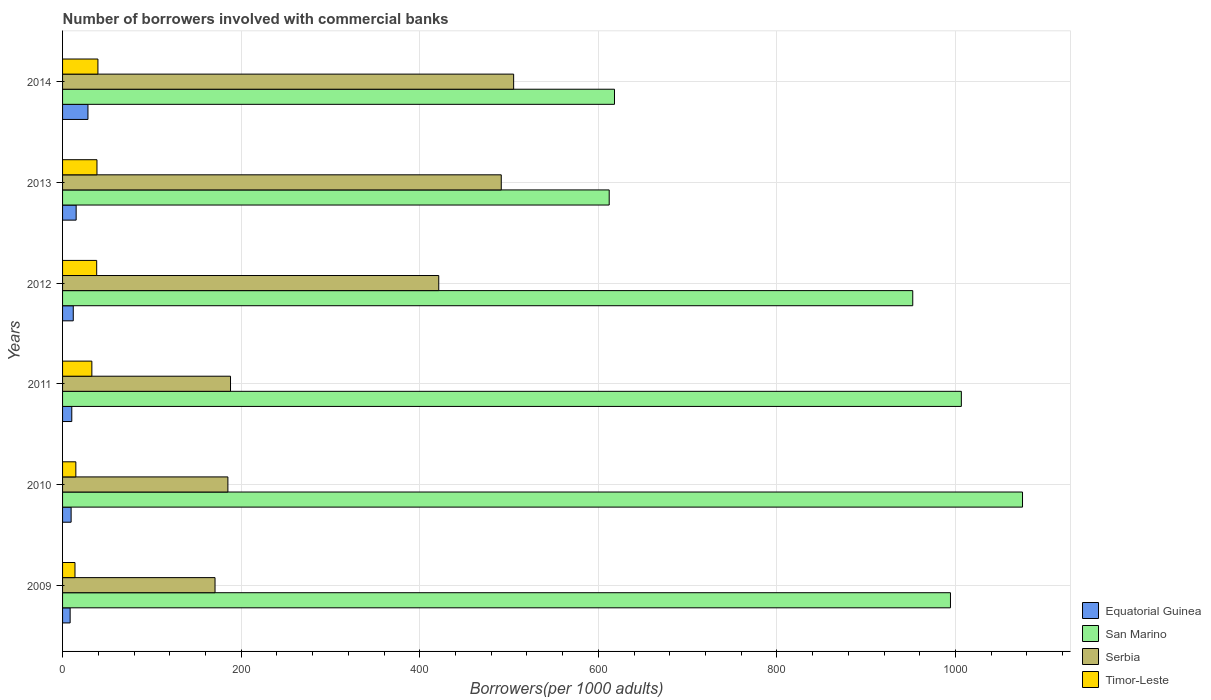What is the label of the 3rd group of bars from the top?
Provide a short and direct response. 2012. What is the number of borrowers involved with commercial banks in San Marino in 2009?
Give a very brief answer. 994.42. Across all years, what is the maximum number of borrowers involved with commercial banks in Equatorial Guinea?
Ensure brevity in your answer.  28.43. Across all years, what is the minimum number of borrowers involved with commercial banks in Serbia?
Offer a very short reply. 170.75. In which year was the number of borrowers involved with commercial banks in Equatorial Guinea minimum?
Offer a very short reply. 2009. What is the total number of borrowers involved with commercial banks in San Marino in the graph?
Give a very brief answer. 5258.57. What is the difference between the number of borrowers involved with commercial banks in Equatorial Guinea in 2012 and that in 2014?
Offer a very short reply. -16.45. What is the difference between the number of borrowers involved with commercial banks in San Marino in 2014 and the number of borrowers involved with commercial banks in Equatorial Guinea in 2013?
Give a very brief answer. 602.9. What is the average number of borrowers involved with commercial banks in Equatorial Guinea per year?
Offer a very short reply. 14. In the year 2013, what is the difference between the number of borrowers involved with commercial banks in Equatorial Guinea and number of borrowers involved with commercial banks in Serbia?
Offer a terse response. -476.1. In how many years, is the number of borrowers involved with commercial banks in Timor-Leste greater than 520 ?
Provide a succinct answer. 0. What is the ratio of the number of borrowers involved with commercial banks in Serbia in 2011 to that in 2013?
Your answer should be very brief. 0.38. Is the difference between the number of borrowers involved with commercial banks in Equatorial Guinea in 2009 and 2010 greater than the difference between the number of borrowers involved with commercial banks in Serbia in 2009 and 2010?
Your answer should be very brief. Yes. What is the difference between the highest and the second highest number of borrowers involved with commercial banks in Timor-Leste?
Keep it short and to the point. 1.07. What is the difference between the highest and the lowest number of borrowers involved with commercial banks in Timor-Leste?
Keep it short and to the point. 25.7. What does the 3rd bar from the top in 2014 represents?
Make the answer very short. San Marino. What does the 1st bar from the bottom in 2014 represents?
Ensure brevity in your answer.  Equatorial Guinea. How many bars are there?
Give a very brief answer. 24. How many years are there in the graph?
Offer a very short reply. 6. What is the difference between two consecutive major ticks on the X-axis?
Offer a terse response. 200. Where does the legend appear in the graph?
Keep it short and to the point. Bottom right. How are the legend labels stacked?
Make the answer very short. Vertical. What is the title of the graph?
Give a very brief answer. Number of borrowers involved with commercial banks. Does "Jordan" appear as one of the legend labels in the graph?
Keep it short and to the point. No. What is the label or title of the X-axis?
Ensure brevity in your answer.  Borrowers(per 1000 adults). What is the label or title of the Y-axis?
Offer a terse response. Years. What is the Borrowers(per 1000 adults) of Equatorial Guinea in 2009?
Your answer should be compact. 8.49. What is the Borrowers(per 1000 adults) of San Marino in 2009?
Your response must be concise. 994.42. What is the Borrowers(per 1000 adults) of Serbia in 2009?
Offer a very short reply. 170.75. What is the Borrowers(per 1000 adults) in Timor-Leste in 2009?
Offer a terse response. 13.9. What is the Borrowers(per 1000 adults) of Equatorial Guinea in 2010?
Keep it short and to the point. 9.58. What is the Borrowers(per 1000 adults) in San Marino in 2010?
Provide a succinct answer. 1075.09. What is the Borrowers(per 1000 adults) of Serbia in 2010?
Offer a terse response. 185.15. What is the Borrowers(per 1000 adults) of Timor-Leste in 2010?
Your response must be concise. 14.87. What is the Borrowers(per 1000 adults) in Equatorial Guinea in 2011?
Your answer should be very brief. 10.32. What is the Borrowers(per 1000 adults) in San Marino in 2011?
Offer a very short reply. 1006.58. What is the Borrowers(per 1000 adults) of Serbia in 2011?
Ensure brevity in your answer.  188.1. What is the Borrowers(per 1000 adults) of Timor-Leste in 2011?
Ensure brevity in your answer.  32.81. What is the Borrowers(per 1000 adults) in Equatorial Guinea in 2012?
Give a very brief answer. 11.98. What is the Borrowers(per 1000 adults) in San Marino in 2012?
Your answer should be compact. 952.16. What is the Borrowers(per 1000 adults) in Serbia in 2012?
Make the answer very short. 421.31. What is the Borrowers(per 1000 adults) of Timor-Leste in 2012?
Keep it short and to the point. 38.21. What is the Borrowers(per 1000 adults) of Equatorial Guinea in 2013?
Keep it short and to the point. 15.22. What is the Borrowers(per 1000 adults) in San Marino in 2013?
Keep it short and to the point. 612.21. What is the Borrowers(per 1000 adults) of Serbia in 2013?
Offer a very short reply. 491.32. What is the Borrowers(per 1000 adults) in Timor-Leste in 2013?
Keep it short and to the point. 38.53. What is the Borrowers(per 1000 adults) of Equatorial Guinea in 2014?
Your answer should be compact. 28.43. What is the Borrowers(per 1000 adults) of San Marino in 2014?
Your answer should be very brief. 618.11. What is the Borrowers(per 1000 adults) of Serbia in 2014?
Make the answer very short. 505.18. What is the Borrowers(per 1000 adults) in Timor-Leste in 2014?
Your response must be concise. 39.6. Across all years, what is the maximum Borrowers(per 1000 adults) in Equatorial Guinea?
Offer a very short reply. 28.43. Across all years, what is the maximum Borrowers(per 1000 adults) of San Marino?
Offer a very short reply. 1075.09. Across all years, what is the maximum Borrowers(per 1000 adults) in Serbia?
Your response must be concise. 505.18. Across all years, what is the maximum Borrowers(per 1000 adults) of Timor-Leste?
Provide a short and direct response. 39.6. Across all years, what is the minimum Borrowers(per 1000 adults) of Equatorial Guinea?
Your answer should be very brief. 8.49. Across all years, what is the minimum Borrowers(per 1000 adults) in San Marino?
Provide a short and direct response. 612.21. Across all years, what is the minimum Borrowers(per 1000 adults) in Serbia?
Your answer should be compact. 170.75. Across all years, what is the minimum Borrowers(per 1000 adults) of Timor-Leste?
Make the answer very short. 13.9. What is the total Borrowers(per 1000 adults) of Equatorial Guinea in the graph?
Offer a terse response. 84.02. What is the total Borrowers(per 1000 adults) of San Marino in the graph?
Keep it short and to the point. 5258.57. What is the total Borrowers(per 1000 adults) in Serbia in the graph?
Provide a short and direct response. 1961.8. What is the total Borrowers(per 1000 adults) in Timor-Leste in the graph?
Offer a terse response. 177.93. What is the difference between the Borrowers(per 1000 adults) of Equatorial Guinea in 2009 and that in 2010?
Your answer should be compact. -1.09. What is the difference between the Borrowers(per 1000 adults) of San Marino in 2009 and that in 2010?
Offer a terse response. -80.68. What is the difference between the Borrowers(per 1000 adults) of Serbia in 2009 and that in 2010?
Make the answer very short. -14.4. What is the difference between the Borrowers(per 1000 adults) in Timor-Leste in 2009 and that in 2010?
Your answer should be compact. -0.97. What is the difference between the Borrowers(per 1000 adults) in Equatorial Guinea in 2009 and that in 2011?
Keep it short and to the point. -1.83. What is the difference between the Borrowers(per 1000 adults) of San Marino in 2009 and that in 2011?
Provide a short and direct response. -12.17. What is the difference between the Borrowers(per 1000 adults) in Serbia in 2009 and that in 2011?
Keep it short and to the point. -17.35. What is the difference between the Borrowers(per 1000 adults) in Timor-Leste in 2009 and that in 2011?
Provide a succinct answer. -18.91. What is the difference between the Borrowers(per 1000 adults) in Equatorial Guinea in 2009 and that in 2012?
Keep it short and to the point. -3.5. What is the difference between the Borrowers(per 1000 adults) in San Marino in 2009 and that in 2012?
Offer a very short reply. 42.26. What is the difference between the Borrowers(per 1000 adults) of Serbia in 2009 and that in 2012?
Your response must be concise. -250.56. What is the difference between the Borrowers(per 1000 adults) in Timor-Leste in 2009 and that in 2012?
Your response must be concise. -24.31. What is the difference between the Borrowers(per 1000 adults) in Equatorial Guinea in 2009 and that in 2013?
Offer a very short reply. -6.73. What is the difference between the Borrowers(per 1000 adults) of San Marino in 2009 and that in 2013?
Give a very brief answer. 382.2. What is the difference between the Borrowers(per 1000 adults) of Serbia in 2009 and that in 2013?
Give a very brief answer. -320.56. What is the difference between the Borrowers(per 1000 adults) of Timor-Leste in 2009 and that in 2013?
Your answer should be very brief. -24.63. What is the difference between the Borrowers(per 1000 adults) in Equatorial Guinea in 2009 and that in 2014?
Provide a succinct answer. -19.94. What is the difference between the Borrowers(per 1000 adults) in San Marino in 2009 and that in 2014?
Offer a very short reply. 376.3. What is the difference between the Borrowers(per 1000 adults) in Serbia in 2009 and that in 2014?
Make the answer very short. -334.43. What is the difference between the Borrowers(per 1000 adults) in Timor-Leste in 2009 and that in 2014?
Keep it short and to the point. -25.7. What is the difference between the Borrowers(per 1000 adults) in Equatorial Guinea in 2010 and that in 2011?
Your response must be concise. -0.74. What is the difference between the Borrowers(per 1000 adults) of San Marino in 2010 and that in 2011?
Offer a very short reply. 68.51. What is the difference between the Borrowers(per 1000 adults) of Serbia in 2010 and that in 2011?
Your answer should be very brief. -2.94. What is the difference between the Borrowers(per 1000 adults) in Timor-Leste in 2010 and that in 2011?
Offer a very short reply. -17.94. What is the difference between the Borrowers(per 1000 adults) of Equatorial Guinea in 2010 and that in 2012?
Your answer should be compact. -2.41. What is the difference between the Borrowers(per 1000 adults) of San Marino in 2010 and that in 2012?
Offer a very short reply. 122.93. What is the difference between the Borrowers(per 1000 adults) of Serbia in 2010 and that in 2012?
Your response must be concise. -236.15. What is the difference between the Borrowers(per 1000 adults) of Timor-Leste in 2010 and that in 2012?
Give a very brief answer. -23.34. What is the difference between the Borrowers(per 1000 adults) in Equatorial Guinea in 2010 and that in 2013?
Give a very brief answer. -5.64. What is the difference between the Borrowers(per 1000 adults) in San Marino in 2010 and that in 2013?
Your answer should be compact. 462.88. What is the difference between the Borrowers(per 1000 adults) in Serbia in 2010 and that in 2013?
Ensure brevity in your answer.  -306.16. What is the difference between the Borrowers(per 1000 adults) in Timor-Leste in 2010 and that in 2013?
Keep it short and to the point. -23.66. What is the difference between the Borrowers(per 1000 adults) of Equatorial Guinea in 2010 and that in 2014?
Provide a succinct answer. -18.86. What is the difference between the Borrowers(per 1000 adults) in San Marino in 2010 and that in 2014?
Provide a succinct answer. 456.98. What is the difference between the Borrowers(per 1000 adults) in Serbia in 2010 and that in 2014?
Ensure brevity in your answer.  -320.02. What is the difference between the Borrowers(per 1000 adults) of Timor-Leste in 2010 and that in 2014?
Provide a succinct answer. -24.73. What is the difference between the Borrowers(per 1000 adults) in Equatorial Guinea in 2011 and that in 2012?
Your answer should be compact. -1.67. What is the difference between the Borrowers(per 1000 adults) of San Marino in 2011 and that in 2012?
Give a very brief answer. 54.42. What is the difference between the Borrowers(per 1000 adults) in Serbia in 2011 and that in 2012?
Offer a terse response. -233.21. What is the difference between the Borrowers(per 1000 adults) of Timor-Leste in 2011 and that in 2012?
Your response must be concise. -5.4. What is the difference between the Borrowers(per 1000 adults) of Equatorial Guinea in 2011 and that in 2013?
Provide a succinct answer. -4.9. What is the difference between the Borrowers(per 1000 adults) in San Marino in 2011 and that in 2013?
Keep it short and to the point. 394.37. What is the difference between the Borrowers(per 1000 adults) of Serbia in 2011 and that in 2013?
Your answer should be very brief. -303.22. What is the difference between the Borrowers(per 1000 adults) of Timor-Leste in 2011 and that in 2013?
Your answer should be compact. -5.72. What is the difference between the Borrowers(per 1000 adults) in Equatorial Guinea in 2011 and that in 2014?
Ensure brevity in your answer.  -18.12. What is the difference between the Borrowers(per 1000 adults) in San Marino in 2011 and that in 2014?
Your answer should be very brief. 388.47. What is the difference between the Borrowers(per 1000 adults) in Serbia in 2011 and that in 2014?
Provide a succinct answer. -317.08. What is the difference between the Borrowers(per 1000 adults) of Timor-Leste in 2011 and that in 2014?
Make the answer very short. -6.79. What is the difference between the Borrowers(per 1000 adults) of Equatorial Guinea in 2012 and that in 2013?
Make the answer very short. -3.23. What is the difference between the Borrowers(per 1000 adults) in San Marino in 2012 and that in 2013?
Make the answer very short. 339.95. What is the difference between the Borrowers(per 1000 adults) in Serbia in 2012 and that in 2013?
Ensure brevity in your answer.  -70.01. What is the difference between the Borrowers(per 1000 adults) in Timor-Leste in 2012 and that in 2013?
Provide a short and direct response. -0.32. What is the difference between the Borrowers(per 1000 adults) in Equatorial Guinea in 2012 and that in 2014?
Your response must be concise. -16.45. What is the difference between the Borrowers(per 1000 adults) in San Marino in 2012 and that in 2014?
Give a very brief answer. 334.05. What is the difference between the Borrowers(per 1000 adults) in Serbia in 2012 and that in 2014?
Make the answer very short. -83.87. What is the difference between the Borrowers(per 1000 adults) in Timor-Leste in 2012 and that in 2014?
Provide a short and direct response. -1.39. What is the difference between the Borrowers(per 1000 adults) of Equatorial Guinea in 2013 and that in 2014?
Your response must be concise. -13.22. What is the difference between the Borrowers(per 1000 adults) of San Marino in 2013 and that in 2014?
Your response must be concise. -5.9. What is the difference between the Borrowers(per 1000 adults) of Serbia in 2013 and that in 2014?
Your answer should be very brief. -13.86. What is the difference between the Borrowers(per 1000 adults) in Timor-Leste in 2013 and that in 2014?
Offer a terse response. -1.07. What is the difference between the Borrowers(per 1000 adults) in Equatorial Guinea in 2009 and the Borrowers(per 1000 adults) in San Marino in 2010?
Make the answer very short. -1066.6. What is the difference between the Borrowers(per 1000 adults) in Equatorial Guinea in 2009 and the Borrowers(per 1000 adults) in Serbia in 2010?
Offer a very short reply. -176.66. What is the difference between the Borrowers(per 1000 adults) in Equatorial Guinea in 2009 and the Borrowers(per 1000 adults) in Timor-Leste in 2010?
Offer a terse response. -6.38. What is the difference between the Borrowers(per 1000 adults) of San Marino in 2009 and the Borrowers(per 1000 adults) of Serbia in 2010?
Make the answer very short. 809.26. What is the difference between the Borrowers(per 1000 adults) of San Marino in 2009 and the Borrowers(per 1000 adults) of Timor-Leste in 2010?
Offer a very short reply. 979.55. What is the difference between the Borrowers(per 1000 adults) of Serbia in 2009 and the Borrowers(per 1000 adults) of Timor-Leste in 2010?
Give a very brief answer. 155.88. What is the difference between the Borrowers(per 1000 adults) of Equatorial Guinea in 2009 and the Borrowers(per 1000 adults) of San Marino in 2011?
Your response must be concise. -998.09. What is the difference between the Borrowers(per 1000 adults) of Equatorial Guinea in 2009 and the Borrowers(per 1000 adults) of Serbia in 2011?
Keep it short and to the point. -179.61. What is the difference between the Borrowers(per 1000 adults) of Equatorial Guinea in 2009 and the Borrowers(per 1000 adults) of Timor-Leste in 2011?
Keep it short and to the point. -24.32. What is the difference between the Borrowers(per 1000 adults) of San Marino in 2009 and the Borrowers(per 1000 adults) of Serbia in 2011?
Your response must be concise. 806.32. What is the difference between the Borrowers(per 1000 adults) in San Marino in 2009 and the Borrowers(per 1000 adults) in Timor-Leste in 2011?
Your answer should be compact. 961.6. What is the difference between the Borrowers(per 1000 adults) in Serbia in 2009 and the Borrowers(per 1000 adults) in Timor-Leste in 2011?
Offer a terse response. 137.94. What is the difference between the Borrowers(per 1000 adults) of Equatorial Guinea in 2009 and the Borrowers(per 1000 adults) of San Marino in 2012?
Ensure brevity in your answer.  -943.67. What is the difference between the Borrowers(per 1000 adults) in Equatorial Guinea in 2009 and the Borrowers(per 1000 adults) in Serbia in 2012?
Provide a short and direct response. -412.82. What is the difference between the Borrowers(per 1000 adults) of Equatorial Guinea in 2009 and the Borrowers(per 1000 adults) of Timor-Leste in 2012?
Provide a succinct answer. -29.72. What is the difference between the Borrowers(per 1000 adults) in San Marino in 2009 and the Borrowers(per 1000 adults) in Serbia in 2012?
Give a very brief answer. 573.11. What is the difference between the Borrowers(per 1000 adults) of San Marino in 2009 and the Borrowers(per 1000 adults) of Timor-Leste in 2012?
Your answer should be very brief. 956.21. What is the difference between the Borrowers(per 1000 adults) in Serbia in 2009 and the Borrowers(per 1000 adults) in Timor-Leste in 2012?
Offer a terse response. 132.54. What is the difference between the Borrowers(per 1000 adults) of Equatorial Guinea in 2009 and the Borrowers(per 1000 adults) of San Marino in 2013?
Provide a succinct answer. -603.72. What is the difference between the Borrowers(per 1000 adults) of Equatorial Guinea in 2009 and the Borrowers(per 1000 adults) of Serbia in 2013?
Keep it short and to the point. -482.83. What is the difference between the Borrowers(per 1000 adults) of Equatorial Guinea in 2009 and the Borrowers(per 1000 adults) of Timor-Leste in 2013?
Keep it short and to the point. -30.04. What is the difference between the Borrowers(per 1000 adults) of San Marino in 2009 and the Borrowers(per 1000 adults) of Serbia in 2013?
Your answer should be compact. 503.1. What is the difference between the Borrowers(per 1000 adults) of San Marino in 2009 and the Borrowers(per 1000 adults) of Timor-Leste in 2013?
Provide a succinct answer. 955.88. What is the difference between the Borrowers(per 1000 adults) in Serbia in 2009 and the Borrowers(per 1000 adults) in Timor-Leste in 2013?
Your answer should be compact. 132.22. What is the difference between the Borrowers(per 1000 adults) of Equatorial Guinea in 2009 and the Borrowers(per 1000 adults) of San Marino in 2014?
Ensure brevity in your answer.  -609.62. What is the difference between the Borrowers(per 1000 adults) of Equatorial Guinea in 2009 and the Borrowers(per 1000 adults) of Serbia in 2014?
Provide a succinct answer. -496.69. What is the difference between the Borrowers(per 1000 adults) in Equatorial Guinea in 2009 and the Borrowers(per 1000 adults) in Timor-Leste in 2014?
Your answer should be very brief. -31.11. What is the difference between the Borrowers(per 1000 adults) in San Marino in 2009 and the Borrowers(per 1000 adults) in Serbia in 2014?
Your answer should be very brief. 489.24. What is the difference between the Borrowers(per 1000 adults) of San Marino in 2009 and the Borrowers(per 1000 adults) of Timor-Leste in 2014?
Your answer should be compact. 954.81. What is the difference between the Borrowers(per 1000 adults) in Serbia in 2009 and the Borrowers(per 1000 adults) in Timor-Leste in 2014?
Ensure brevity in your answer.  131.15. What is the difference between the Borrowers(per 1000 adults) of Equatorial Guinea in 2010 and the Borrowers(per 1000 adults) of San Marino in 2011?
Your answer should be compact. -997. What is the difference between the Borrowers(per 1000 adults) in Equatorial Guinea in 2010 and the Borrowers(per 1000 adults) in Serbia in 2011?
Keep it short and to the point. -178.52. What is the difference between the Borrowers(per 1000 adults) in Equatorial Guinea in 2010 and the Borrowers(per 1000 adults) in Timor-Leste in 2011?
Provide a succinct answer. -23.23. What is the difference between the Borrowers(per 1000 adults) of San Marino in 2010 and the Borrowers(per 1000 adults) of Serbia in 2011?
Your answer should be very brief. 886.99. What is the difference between the Borrowers(per 1000 adults) of San Marino in 2010 and the Borrowers(per 1000 adults) of Timor-Leste in 2011?
Make the answer very short. 1042.28. What is the difference between the Borrowers(per 1000 adults) in Serbia in 2010 and the Borrowers(per 1000 adults) in Timor-Leste in 2011?
Your answer should be compact. 152.34. What is the difference between the Borrowers(per 1000 adults) of Equatorial Guinea in 2010 and the Borrowers(per 1000 adults) of San Marino in 2012?
Offer a terse response. -942.58. What is the difference between the Borrowers(per 1000 adults) in Equatorial Guinea in 2010 and the Borrowers(per 1000 adults) in Serbia in 2012?
Give a very brief answer. -411.73. What is the difference between the Borrowers(per 1000 adults) in Equatorial Guinea in 2010 and the Borrowers(per 1000 adults) in Timor-Leste in 2012?
Make the answer very short. -28.63. What is the difference between the Borrowers(per 1000 adults) in San Marino in 2010 and the Borrowers(per 1000 adults) in Serbia in 2012?
Offer a terse response. 653.78. What is the difference between the Borrowers(per 1000 adults) in San Marino in 2010 and the Borrowers(per 1000 adults) in Timor-Leste in 2012?
Give a very brief answer. 1036.88. What is the difference between the Borrowers(per 1000 adults) of Serbia in 2010 and the Borrowers(per 1000 adults) of Timor-Leste in 2012?
Keep it short and to the point. 146.95. What is the difference between the Borrowers(per 1000 adults) of Equatorial Guinea in 2010 and the Borrowers(per 1000 adults) of San Marino in 2013?
Provide a succinct answer. -602.63. What is the difference between the Borrowers(per 1000 adults) in Equatorial Guinea in 2010 and the Borrowers(per 1000 adults) in Serbia in 2013?
Your answer should be very brief. -481.74. What is the difference between the Borrowers(per 1000 adults) of Equatorial Guinea in 2010 and the Borrowers(per 1000 adults) of Timor-Leste in 2013?
Provide a succinct answer. -28.96. What is the difference between the Borrowers(per 1000 adults) in San Marino in 2010 and the Borrowers(per 1000 adults) in Serbia in 2013?
Keep it short and to the point. 583.78. What is the difference between the Borrowers(per 1000 adults) in San Marino in 2010 and the Borrowers(per 1000 adults) in Timor-Leste in 2013?
Give a very brief answer. 1036.56. What is the difference between the Borrowers(per 1000 adults) in Serbia in 2010 and the Borrowers(per 1000 adults) in Timor-Leste in 2013?
Provide a succinct answer. 146.62. What is the difference between the Borrowers(per 1000 adults) in Equatorial Guinea in 2010 and the Borrowers(per 1000 adults) in San Marino in 2014?
Offer a very short reply. -608.54. What is the difference between the Borrowers(per 1000 adults) in Equatorial Guinea in 2010 and the Borrowers(per 1000 adults) in Serbia in 2014?
Ensure brevity in your answer.  -495.6. What is the difference between the Borrowers(per 1000 adults) of Equatorial Guinea in 2010 and the Borrowers(per 1000 adults) of Timor-Leste in 2014?
Keep it short and to the point. -30.03. What is the difference between the Borrowers(per 1000 adults) of San Marino in 2010 and the Borrowers(per 1000 adults) of Serbia in 2014?
Your response must be concise. 569.91. What is the difference between the Borrowers(per 1000 adults) of San Marino in 2010 and the Borrowers(per 1000 adults) of Timor-Leste in 2014?
Your answer should be very brief. 1035.49. What is the difference between the Borrowers(per 1000 adults) of Serbia in 2010 and the Borrowers(per 1000 adults) of Timor-Leste in 2014?
Your response must be concise. 145.55. What is the difference between the Borrowers(per 1000 adults) in Equatorial Guinea in 2011 and the Borrowers(per 1000 adults) in San Marino in 2012?
Your answer should be compact. -941.84. What is the difference between the Borrowers(per 1000 adults) of Equatorial Guinea in 2011 and the Borrowers(per 1000 adults) of Serbia in 2012?
Your response must be concise. -410.99. What is the difference between the Borrowers(per 1000 adults) of Equatorial Guinea in 2011 and the Borrowers(per 1000 adults) of Timor-Leste in 2012?
Your answer should be compact. -27.89. What is the difference between the Borrowers(per 1000 adults) in San Marino in 2011 and the Borrowers(per 1000 adults) in Serbia in 2012?
Ensure brevity in your answer.  585.27. What is the difference between the Borrowers(per 1000 adults) in San Marino in 2011 and the Borrowers(per 1000 adults) in Timor-Leste in 2012?
Make the answer very short. 968.37. What is the difference between the Borrowers(per 1000 adults) of Serbia in 2011 and the Borrowers(per 1000 adults) of Timor-Leste in 2012?
Your answer should be compact. 149.89. What is the difference between the Borrowers(per 1000 adults) in Equatorial Guinea in 2011 and the Borrowers(per 1000 adults) in San Marino in 2013?
Your answer should be compact. -601.89. What is the difference between the Borrowers(per 1000 adults) of Equatorial Guinea in 2011 and the Borrowers(per 1000 adults) of Serbia in 2013?
Offer a terse response. -481. What is the difference between the Borrowers(per 1000 adults) in Equatorial Guinea in 2011 and the Borrowers(per 1000 adults) in Timor-Leste in 2013?
Your answer should be compact. -28.22. What is the difference between the Borrowers(per 1000 adults) of San Marino in 2011 and the Borrowers(per 1000 adults) of Serbia in 2013?
Ensure brevity in your answer.  515.27. What is the difference between the Borrowers(per 1000 adults) in San Marino in 2011 and the Borrowers(per 1000 adults) in Timor-Leste in 2013?
Give a very brief answer. 968.05. What is the difference between the Borrowers(per 1000 adults) in Serbia in 2011 and the Borrowers(per 1000 adults) in Timor-Leste in 2013?
Provide a short and direct response. 149.56. What is the difference between the Borrowers(per 1000 adults) in Equatorial Guinea in 2011 and the Borrowers(per 1000 adults) in San Marino in 2014?
Provide a succinct answer. -607.8. What is the difference between the Borrowers(per 1000 adults) in Equatorial Guinea in 2011 and the Borrowers(per 1000 adults) in Serbia in 2014?
Provide a short and direct response. -494.86. What is the difference between the Borrowers(per 1000 adults) of Equatorial Guinea in 2011 and the Borrowers(per 1000 adults) of Timor-Leste in 2014?
Offer a terse response. -29.28. What is the difference between the Borrowers(per 1000 adults) in San Marino in 2011 and the Borrowers(per 1000 adults) in Serbia in 2014?
Ensure brevity in your answer.  501.41. What is the difference between the Borrowers(per 1000 adults) in San Marino in 2011 and the Borrowers(per 1000 adults) in Timor-Leste in 2014?
Offer a terse response. 966.98. What is the difference between the Borrowers(per 1000 adults) of Serbia in 2011 and the Borrowers(per 1000 adults) of Timor-Leste in 2014?
Offer a very short reply. 148.5. What is the difference between the Borrowers(per 1000 adults) of Equatorial Guinea in 2012 and the Borrowers(per 1000 adults) of San Marino in 2013?
Your answer should be compact. -600.23. What is the difference between the Borrowers(per 1000 adults) in Equatorial Guinea in 2012 and the Borrowers(per 1000 adults) in Serbia in 2013?
Offer a terse response. -479.33. What is the difference between the Borrowers(per 1000 adults) of Equatorial Guinea in 2012 and the Borrowers(per 1000 adults) of Timor-Leste in 2013?
Keep it short and to the point. -26.55. What is the difference between the Borrowers(per 1000 adults) in San Marino in 2012 and the Borrowers(per 1000 adults) in Serbia in 2013?
Keep it short and to the point. 460.84. What is the difference between the Borrowers(per 1000 adults) of San Marino in 2012 and the Borrowers(per 1000 adults) of Timor-Leste in 2013?
Your answer should be compact. 913.63. What is the difference between the Borrowers(per 1000 adults) of Serbia in 2012 and the Borrowers(per 1000 adults) of Timor-Leste in 2013?
Give a very brief answer. 382.77. What is the difference between the Borrowers(per 1000 adults) in Equatorial Guinea in 2012 and the Borrowers(per 1000 adults) in San Marino in 2014?
Ensure brevity in your answer.  -606.13. What is the difference between the Borrowers(per 1000 adults) of Equatorial Guinea in 2012 and the Borrowers(per 1000 adults) of Serbia in 2014?
Provide a short and direct response. -493.19. What is the difference between the Borrowers(per 1000 adults) of Equatorial Guinea in 2012 and the Borrowers(per 1000 adults) of Timor-Leste in 2014?
Give a very brief answer. -27.62. What is the difference between the Borrowers(per 1000 adults) in San Marino in 2012 and the Borrowers(per 1000 adults) in Serbia in 2014?
Keep it short and to the point. 446.98. What is the difference between the Borrowers(per 1000 adults) of San Marino in 2012 and the Borrowers(per 1000 adults) of Timor-Leste in 2014?
Your answer should be compact. 912.56. What is the difference between the Borrowers(per 1000 adults) of Serbia in 2012 and the Borrowers(per 1000 adults) of Timor-Leste in 2014?
Your answer should be compact. 381.71. What is the difference between the Borrowers(per 1000 adults) of Equatorial Guinea in 2013 and the Borrowers(per 1000 adults) of San Marino in 2014?
Your answer should be very brief. -602.9. What is the difference between the Borrowers(per 1000 adults) of Equatorial Guinea in 2013 and the Borrowers(per 1000 adults) of Serbia in 2014?
Keep it short and to the point. -489.96. What is the difference between the Borrowers(per 1000 adults) of Equatorial Guinea in 2013 and the Borrowers(per 1000 adults) of Timor-Leste in 2014?
Your answer should be compact. -24.39. What is the difference between the Borrowers(per 1000 adults) in San Marino in 2013 and the Borrowers(per 1000 adults) in Serbia in 2014?
Keep it short and to the point. 107.04. What is the difference between the Borrowers(per 1000 adults) of San Marino in 2013 and the Borrowers(per 1000 adults) of Timor-Leste in 2014?
Offer a terse response. 572.61. What is the difference between the Borrowers(per 1000 adults) in Serbia in 2013 and the Borrowers(per 1000 adults) in Timor-Leste in 2014?
Your answer should be compact. 451.71. What is the average Borrowers(per 1000 adults) in Equatorial Guinea per year?
Your answer should be compact. 14. What is the average Borrowers(per 1000 adults) of San Marino per year?
Give a very brief answer. 876.43. What is the average Borrowers(per 1000 adults) of Serbia per year?
Your answer should be very brief. 326.97. What is the average Borrowers(per 1000 adults) of Timor-Leste per year?
Your answer should be compact. 29.65. In the year 2009, what is the difference between the Borrowers(per 1000 adults) of Equatorial Guinea and Borrowers(per 1000 adults) of San Marino?
Keep it short and to the point. -985.93. In the year 2009, what is the difference between the Borrowers(per 1000 adults) of Equatorial Guinea and Borrowers(per 1000 adults) of Serbia?
Keep it short and to the point. -162.26. In the year 2009, what is the difference between the Borrowers(per 1000 adults) of Equatorial Guinea and Borrowers(per 1000 adults) of Timor-Leste?
Provide a succinct answer. -5.41. In the year 2009, what is the difference between the Borrowers(per 1000 adults) in San Marino and Borrowers(per 1000 adults) in Serbia?
Provide a short and direct response. 823.66. In the year 2009, what is the difference between the Borrowers(per 1000 adults) of San Marino and Borrowers(per 1000 adults) of Timor-Leste?
Keep it short and to the point. 980.51. In the year 2009, what is the difference between the Borrowers(per 1000 adults) of Serbia and Borrowers(per 1000 adults) of Timor-Leste?
Make the answer very short. 156.85. In the year 2010, what is the difference between the Borrowers(per 1000 adults) of Equatorial Guinea and Borrowers(per 1000 adults) of San Marino?
Provide a short and direct response. -1065.51. In the year 2010, what is the difference between the Borrowers(per 1000 adults) of Equatorial Guinea and Borrowers(per 1000 adults) of Serbia?
Provide a short and direct response. -175.58. In the year 2010, what is the difference between the Borrowers(per 1000 adults) of Equatorial Guinea and Borrowers(per 1000 adults) of Timor-Leste?
Ensure brevity in your answer.  -5.29. In the year 2010, what is the difference between the Borrowers(per 1000 adults) of San Marino and Borrowers(per 1000 adults) of Serbia?
Make the answer very short. 889.94. In the year 2010, what is the difference between the Borrowers(per 1000 adults) in San Marino and Borrowers(per 1000 adults) in Timor-Leste?
Offer a very short reply. 1060.22. In the year 2010, what is the difference between the Borrowers(per 1000 adults) in Serbia and Borrowers(per 1000 adults) in Timor-Leste?
Provide a succinct answer. 170.28. In the year 2011, what is the difference between the Borrowers(per 1000 adults) of Equatorial Guinea and Borrowers(per 1000 adults) of San Marino?
Your response must be concise. -996.26. In the year 2011, what is the difference between the Borrowers(per 1000 adults) of Equatorial Guinea and Borrowers(per 1000 adults) of Serbia?
Keep it short and to the point. -177.78. In the year 2011, what is the difference between the Borrowers(per 1000 adults) of Equatorial Guinea and Borrowers(per 1000 adults) of Timor-Leste?
Your response must be concise. -22.49. In the year 2011, what is the difference between the Borrowers(per 1000 adults) of San Marino and Borrowers(per 1000 adults) of Serbia?
Your response must be concise. 818.48. In the year 2011, what is the difference between the Borrowers(per 1000 adults) in San Marino and Borrowers(per 1000 adults) in Timor-Leste?
Provide a short and direct response. 973.77. In the year 2011, what is the difference between the Borrowers(per 1000 adults) of Serbia and Borrowers(per 1000 adults) of Timor-Leste?
Provide a short and direct response. 155.29. In the year 2012, what is the difference between the Borrowers(per 1000 adults) in Equatorial Guinea and Borrowers(per 1000 adults) in San Marino?
Offer a very short reply. -940.18. In the year 2012, what is the difference between the Borrowers(per 1000 adults) in Equatorial Guinea and Borrowers(per 1000 adults) in Serbia?
Make the answer very short. -409.32. In the year 2012, what is the difference between the Borrowers(per 1000 adults) of Equatorial Guinea and Borrowers(per 1000 adults) of Timor-Leste?
Offer a terse response. -26.22. In the year 2012, what is the difference between the Borrowers(per 1000 adults) in San Marino and Borrowers(per 1000 adults) in Serbia?
Your answer should be very brief. 530.85. In the year 2012, what is the difference between the Borrowers(per 1000 adults) of San Marino and Borrowers(per 1000 adults) of Timor-Leste?
Provide a succinct answer. 913.95. In the year 2012, what is the difference between the Borrowers(per 1000 adults) in Serbia and Borrowers(per 1000 adults) in Timor-Leste?
Make the answer very short. 383.1. In the year 2013, what is the difference between the Borrowers(per 1000 adults) in Equatorial Guinea and Borrowers(per 1000 adults) in San Marino?
Keep it short and to the point. -597. In the year 2013, what is the difference between the Borrowers(per 1000 adults) of Equatorial Guinea and Borrowers(per 1000 adults) of Serbia?
Your response must be concise. -476.1. In the year 2013, what is the difference between the Borrowers(per 1000 adults) of Equatorial Guinea and Borrowers(per 1000 adults) of Timor-Leste?
Provide a short and direct response. -23.32. In the year 2013, what is the difference between the Borrowers(per 1000 adults) of San Marino and Borrowers(per 1000 adults) of Serbia?
Provide a short and direct response. 120.9. In the year 2013, what is the difference between the Borrowers(per 1000 adults) of San Marino and Borrowers(per 1000 adults) of Timor-Leste?
Provide a succinct answer. 573.68. In the year 2013, what is the difference between the Borrowers(per 1000 adults) of Serbia and Borrowers(per 1000 adults) of Timor-Leste?
Offer a terse response. 452.78. In the year 2014, what is the difference between the Borrowers(per 1000 adults) of Equatorial Guinea and Borrowers(per 1000 adults) of San Marino?
Give a very brief answer. -589.68. In the year 2014, what is the difference between the Borrowers(per 1000 adults) of Equatorial Guinea and Borrowers(per 1000 adults) of Serbia?
Your response must be concise. -476.74. In the year 2014, what is the difference between the Borrowers(per 1000 adults) of Equatorial Guinea and Borrowers(per 1000 adults) of Timor-Leste?
Offer a terse response. -11.17. In the year 2014, what is the difference between the Borrowers(per 1000 adults) in San Marino and Borrowers(per 1000 adults) in Serbia?
Your answer should be very brief. 112.94. In the year 2014, what is the difference between the Borrowers(per 1000 adults) of San Marino and Borrowers(per 1000 adults) of Timor-Leste?
Offer a very short reply. 578.51. In the year 2014, what is the difference between the Borrowers(per 1000 adults) in Serbia and Borrowers(per 1000 adults) in Timor-Leste?
Your answer should be very brief. 465.57. What is the ratio of the Borrowers(per 1000 adults) in Equatorial Guinea in 2009 to that in 2010?
Give a very brief answer. 0.89. What is the ratio of the Borrowers(per 1000 adults) of San Marino in 2009 to that in 2010?
Ensure brevity in your answer.  0.93. What is the ratio of the Borrowers(per 1000 adults) of Serbia in 2009 to that in 2010?
Give a very brief answer. 0.92. What is the ratio of the Borrowers(per 1000 adults) in Timor-Leste in 2009 to that in 2010?
Offer a very short reply. 0.94. What is the ratio of the Borrowers(per 1000 adults) of Equatorial Guinea in 2009 to that in 2011?
Your response must be concise. 0.82. What is the ratio of the Borrowers(per 1000 adults) of San Marino in 2009 to that in 2011?
Your response must be concise. 0.99. What is the ratio of the Borrowers(per 1000 adults) of Serbia in 2009 to that in 2011?
Your answer should be very brief. 0.91. What is the ratio of the Borrowers(per 1000 adults) in Timor-Leste in 2009 to that in 2011?
Ensure brevity in your answer.  0.42. What is the ratio of the Borrowers(per 1000 adults) in Equatorial Guinea in 2009 to that in 2012?
Make the answer very short. 0.71. What is the ratio of the Borrowers(per 1000 adults) in San Marino in 2009 to that in 2012?
Ensure brevity in your answer.  1.04. What is the ratio of the Borrowers(per 1000 adults) in Serbia in 2009 to that in 2012?
Keep it short and to the point. 0.41. What is the ratio of the Borrowers(per 1000 adults) of Timor-Leste in 2009 to that in 2012?
Offer a very short reply. 0.36. What is the ratio of the Borrowers(per 1000 adults) in Equatorial Guinea in 2009 to that in 2013?
Provide a succinct answer. 0.56. What is the ratio of the Borrowers(per 1000 adults) in San Marino in 2009 to that in 2013?
Ensure brevity in your answer.  1.62. What is the ratio of the Borrowers(per 1000 adults) in Serbia in 2009 to that in 2013?
Your answer should be compact. 0.35. What is the ratio of the Borrowers(per 1000 adults) in Timor-Leste in 2009 to that in 2013?
Your answer should be compact. 0.36. What is the ratio of the Borrowers(per 1000 adults) of Equatorial Guinea in 2009 to that in 2014?
Offer a very short reply. 0.3. What is the ratio of the Borrowers(per 1000 adults) of San Marino in 2009 to that in 2014?
Provide a succinct answer. 1.61. What is the ratio of the Borrowers(per 1000 adults) of Serbia in 2009 to that in 2014?
Give a very brief answer. 0.34. What is the ratio of the Borrowers(per 1000 adults) in Timor-Leste in 2009 to that in 2014?
Your answer should be compact. 0.35. What is the ratio of the Borrowers(per 1000 adults) of Equatorial Guinea in 2010 to that in 2011?
Offer a very short reply. 0.93. What is the ratio of the Borrowers(per 1000 adults) of San Marino in 2010 to that in 2011?
Your answer should be very brief. 1.07. What is the ratio of the Borrowers(per 1000 adults) in Serbia in 2010 to that in 2011?
Your response must be concise. 0.98. What is the ratio of the Borrowers(per 1000 adults) in Timor-Leste in 2010 to that in 2011?
Keep it short and to the point. 0.45. What is the ratio of the Borrowers(per 1000 adults) of Equatorial Guinea in 2010 to that in 2012?
Ensure brevity in your answer.  0.8. What is the ratio of the Borrowers(per 1000 adults) in San Marino in 2010 to that in 2012?
Provide a succinct answer. 1.13. What is the ratio of the Borrowers(per 1000 adults) in Serbia in 2010 to that in 2012?
Give a very brief answer. 0.44. What is the ratio of the Borrowers(per 1000 adults) of Timor-Leste in 2010 to that in 2012?
Give a very brief answer. 0.39. What is the ratio of the Borrowers(per 1000 adults) of Equatorial Guinea in 2010 to that in 2013?
Offer a terse response. 0.63. What is the ratio of the Borrowers(per 1000 adults) in San Marino in 2010 to that in 2013?
Provide a succinct answer. 1.76. What is the ratio of the Borrowers(per 1000 adults) in Serbia in 2010 to that in 2013?
Provide a short and direct response. 0.38. What is the ratio of the Borrowers(per 1000 adults) in Timor-Leste in 2010 to that in 2013?
Your answer should be very brief. 0.39. What is the ratio of the Borrowers(per 1000 adults) of Equatorial Guinea in 2010 to that in 2014?
Offer a terse response. 0.34. What is the ratio of the Borrowers(per 1000 adults) in San Marino in 2010 to that in 2014?
Offer a very short reply. 1.74. What is the ratio of the Borrowers(per 1000 adults) of Serbia in 2010 to that in 2014?
Give a very brief answer. 0.37. What is the ratio of the Borrowers(per 1000 adults) in Timor-Leste in 2010 to that in 2014?
Your response must be concise. 0.38. What is the ratio of the Borrowers(per 1000 adults) of Equatorial Guinea in 2011 to that in 2012?
Make the answer very short. 0.86. What is the ratio of the Borrowers(per 1000 adults) of San Marino in 2011 to that in 2012?
Provide a short and direct response. 1.06. What is the ratio of the Borrowers(per 1000 adults) of Serbia in 2011 to that in 2012?
Your answer should be compact. 0.45. What is the ratio of the Borrowers(per 1000 adults) in Timor-Leste in 2011 to that in 2012?
Provide a succinct answer. 0.86. What is the ratio of the Borrowers(per 1000 adults) of Equatorial Guinea in 2011 to that in 2013?
Ensure brevity in your answer.  0.68. What is the ratio of the Borrowers(per 1000 adults) in San Marino in 2011 to that in 2013?
Your answer should be compact. 1.64. What is the ratio of the Borrowers(per 1000 adults) of Serbia in 2011 to that in 2013?
Your answer should be compact. 0.38. What is the ratio of the Borrowers(per 1000 adults) of Timor-Leste in 2011 to that in 2013?
Provide a succinct answer. 0.85. What is the ratio of the Borrowers(per 1000 adults) of Equatorial Guinea in 2011 to that in 2014?
Give a very brief answer. 0.36. What is the ratio of the Borrowers(per 1000 adults) of San Marino in 2011 to that in 2014?
Give a very brief answer. 1.63. What is the ratio of the Borrowers(per 1000 adults) in Serbia in 2011 to that in 2014?
Provide a succinct answer. 0.37. What is the ratio of the Borrowers(per 1000 adults) in Timor-Leste in 2011 to that in 2014?
Your answer should be very brief. 0.83. What is the ratio of the Borrowers(per 1000 adults) in Equatorial Guinea in 2012 to that in 2013?
Make the answer very short. 0.79. What is the ratio of the Borrowers(per 1000 adults) of San Marino in 2012 to that in 2013?
Your response must be concise. 1.56. What is the ratio of the Borrowers(per 1000 adults) of Serbia in 2012 to that in 2013?
Offer a terse response. 0.86. What is the ratio of the Borrowers(per 1000 adults) in Equatorial Guinea in 2012 to that in 2014?
Ensure brevity in your answer.  0.42. What is the ratio of the Borrowers(per 1000 adults) in San Marino in 2012 to that in 2014?
Offer a very short reply. 1.54. What is the ratio of the Borrowers(per 1000 adults) in Serbia in 2012 to that in 2014?
Offer a terse response. 0.83. What is the ratio of the Borrowers(per 1000 adults) in Timor-Leste in 2012 to that in 2014?
Ensure brevity in your answer.  0.96. What is the ratio of the Borrowers(per 1000 adults) in Equatorial Guinea in 2013 to that in 2014?
Your answer should be very brief. 0.54. What is the ratio of the Borrowers(per 1000 adults) in San Marino in 2013 to that in 2014?
Your answer should be compact. 0.99. What is the ratio of the Borrowers(per 1000 adults) in Serbia in 2013 to that in 2014?
Ensure brevity in your answer.  0.97. What is the ratio of the Borrowers(per 1000 adults) of Timor-Leste in 2013 to that in 2014?
Provide a succinct answer. 0.97. What is the difference between the highest and the second highest Borrowers(per 1000 adults) in Equatorial Guinea?
Provide a short and direct response. 13.22. What is the difference between the highest and the second highest Borrowers(per 1000 adults) of San Marino?
Provide a succinct answer. 68.51. What is the difference between the highest and the second highest Borrowers(per 1000 adults) in Serbia?
Keep it short and to the point. 13.86. What is the difference between the highest and the second highest Borrowers(per 1000 adults) in Timor-Leste?
Your response must be concise. 1.07. What is the difference between the highest and the lowest Borrowers(per 1000 adults) in Equatorial Guinea?
Give a very brief answer. 19.94. What is the difference between the highest and the lowest Borrowers(per 1000 adults) in San Marino?
Offer a very short reply. 462.88. What is the difference between the highest and the lowest Borrowers(per 1000 adults) in Serbia?
Your answer should be very brief. 334.43. What is the difference between the highest and the lowest Borrowers(per 1000 adults) of Timor-Leste?
Your answer should be very brief. 25.7. 